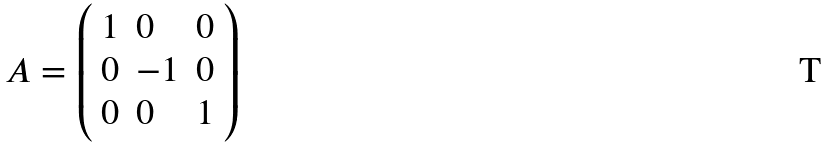<formula> <loc_0><loc_0><loc_500><loc_500>A = \left ( \begin{array} { l l l } { 1 } & { 0 } & { 0 } \\ { 0 } & { - 1 } & { 0 } \\ { 0 } & { 0 } & { 1 } \end{array} \right )</formula> 